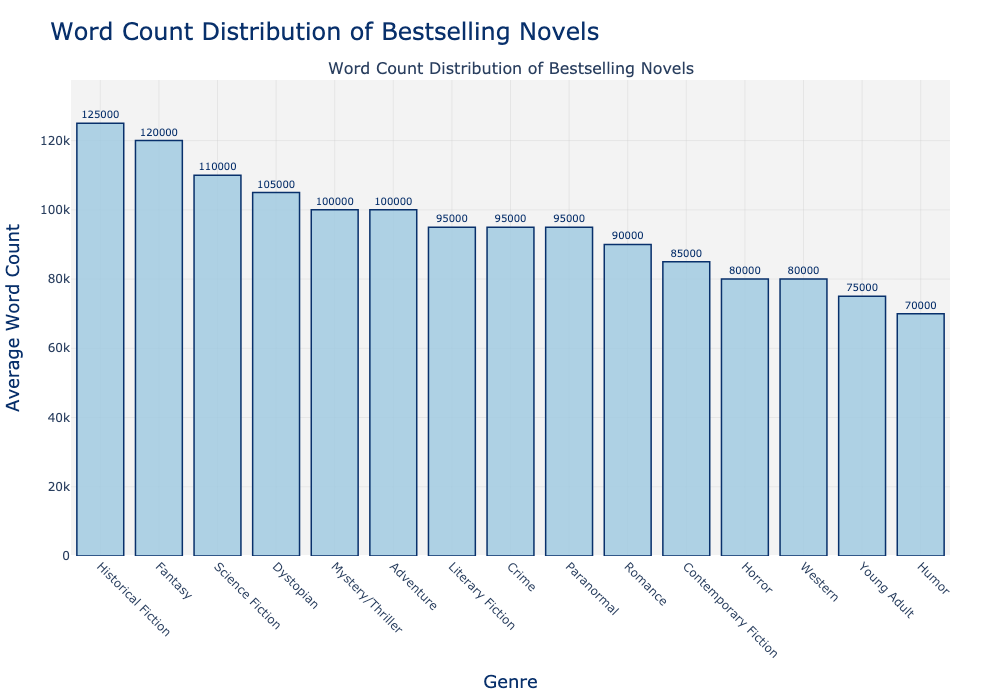Which genre has the highest average word count? The genre with the tallest bar represents the highest average word count. By observing the plot, Historical Fiction has the tallest bar.
Answer: Historical Fiction Which genres have an average word count greater than 100,000? To find this, identify all the genres with bars extending above the 100,000 mark on the y-axis. These genres are Historical Fiction, Fantasy, Science Fiction, and Dystopian.
Answer: Historical Fiction, Fantasy, Science Fiction, Dystopian Which genre has a lower average word count: Romance or Crime? Compare the heights of the bars for Romance and Crime. The bar for Romance reaches up to 90,000, while the bar for Crime reaches up to 95,000.
Answer: Romance What is the difference in average word count between Historical Fiction and Humor? Find the heights of the bars for Historical Fiction and Humor. Historical Fiction has an average word count of 125,000 and Humor has 70,000. The difference is 125,000 - 70,000.
Answer: 55,000 Which two genres have the closest average word counts? Look for bars with almost equal heights. The bars for Literary Fiction and Paranormal are very close, both around 95,000.
Answer: Literary Fiction, Paranormal Rank the top three genres by average word count. The tallest three bars represent the top three genres. From tallest to shortest, the genres are Historical Fiction, Fantasy, and Science Fiction.
Answer: Historical Fiction, Fantasy, Science Fiction How much higher is the average word count for Science Fiction compared to Young Adult? Subtract the average word count of Young Adult (75,000) from that of Science Fiction (110,000).
Answer: 35,000 Is the average word count of Western lower than that of Contemporary Fiction? Compare the heights of the bars for Western and Contemporary Fiction. The bar for Western reaches 80,000 and Contemporary Fiction reaches 85,000, so yes.
Answer: Yes What is the combined average word count of Mystery/Thriller and Adventure? Add the average word counts for Mystery/Thriller (100,000) and Adventure (100,000). The sum is 100,000 + 100,000.
Answer: 200,000 How many genres have an average word count fewer than 80,000? Count the number of bars that do not reach the 80,000 mark on the y-axis. Only Horror and Humor have bars that are under 80,000.
Answer: 2 